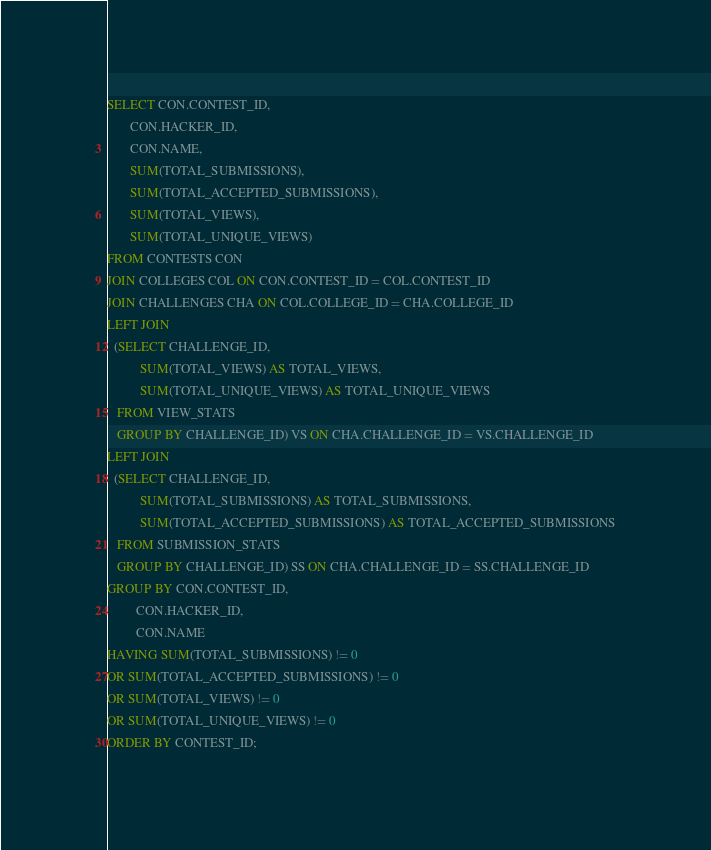<code> <loc_0><loc_0><loc_500><loc_500><_SQL_>SELECT CON.CONTEST_ID,
       CON.HACKER_ID,
       CON.NAME,
       SUM(TOTAL_SUBMISSIONS),
       SUM(TOTAL_ACCEPTED_SUBMISSIONS),
       SUM(TOTAL_VIEWS),
       SUM(TOTAL_UNIQUE_VIEWS)
FROM CONTESTS CON
JOIN COLLEGES COL ON CON.CONTEST_ID = COL.CONTEST_ID
JOIN CHALLENGES CHA ON COL.COLLEGE_ID = CHA.COLLEGE_ID
LEFT JOIN
  (SELECT CHALLENGE_ID,
          SUM(TOTAL_VIEWS) AS TOTAL_VIEWS,
          SUM(TOTAL_UNIQUE_VIEWS) AS TOTAL_UNIQUE_VIEWS
   FROM VIEW_STATS
   GROUP BY CHALLENGE_ID) VS ON CHA.CHALLENGE_ID = VS.CHALLENGE_ID
LEFT JOIN
  (SELECT CHALLENGE_ID,
          SUM(TOTAL_SUBMISSIONS) AS TOTAL_SUBMISSIONS,
          SUM(TOTAL_ACCEPTED_SUBMISSIONS) AS TOTAL_ACCEPTED_SUBMISSIONS
   FROM SUBMISSION_STATS
   GROUP BY CHALLENGE_ID) SS ON CHA.CHALLENGE_ID = SS.CHALLENGE_ID
GROUP BY CON.CONTEST_ID,
         CON.HACKER_ID,
         CON.NAME
HAVING SUM(TOTAL_SUBMISSIONS) != 0
OR SUM(TOTAL_ACCEPTED_SUBMISSIONS) != 0
OR SUM(TOTAL_VIEWS) != 0
OR SUM(TOTAL_UNIQUE_VIEWS) != 0
ORDER BY CONTEST_ID;</code> 